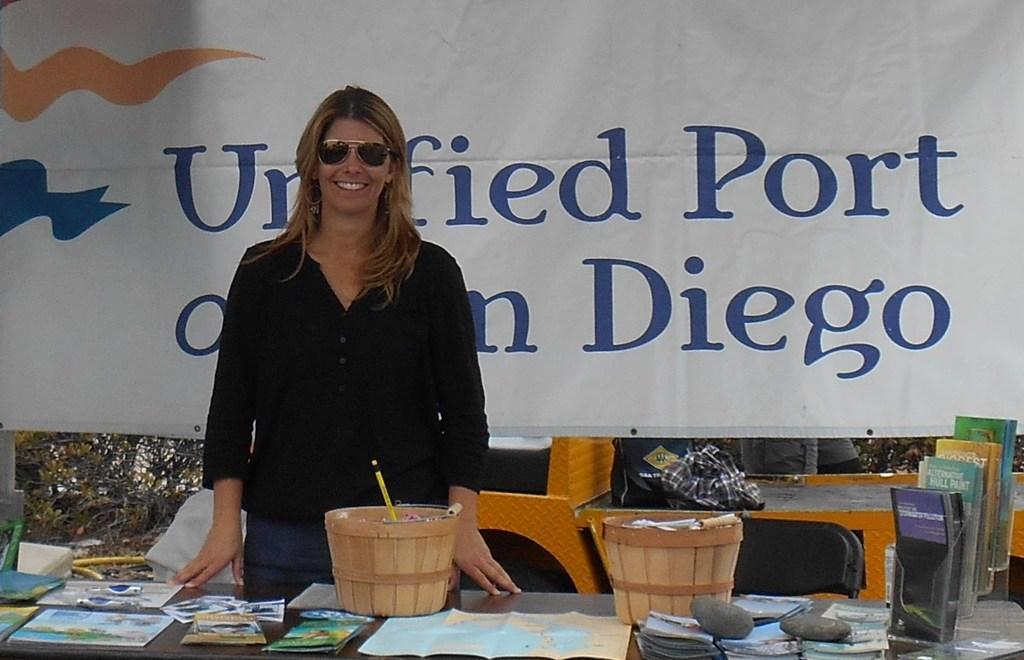Can you describe this image briefly? In this image i can see a woman standing in front of a table on which there are few papers, few books and two baskets. In the background i can see a banner, few books and trees. 